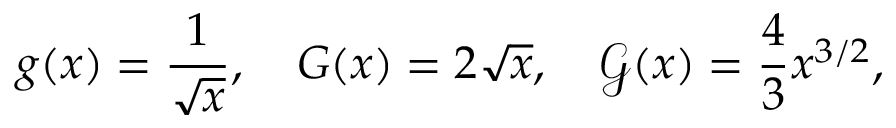Convert formula to latex. <formula><loc_0><loc_0><loc_500><loc_500>g ( x ) = \frac { 1 } { \sqrt { x } } , \quad G ( x ) = 2 \sqrt { x } , \quad \mathcal { G } ( x ) = \frac { 4 } { 3 } x ^ { 3 / 2 } ,</formula> 